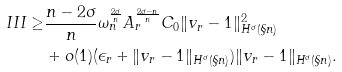Convert formula to latex. <formula><loc_0><loc_0><loc_500><loc_500>I I I \geq & \frac { n - 2 \sigma } { n } \omega _ { n } ^ { \frac { 2 \sigma } { n } } A _ { r } ^ { \frac { 2 \sigma - n } { n } } C _ { 0 } \| v _ { r } - 1 \| _ { H ^ { \sigma } ( \S n ) } ^ { 2 } \\ & + o ( 1 ) ( \epsilon _ { r } + \| v _ { r } - 1 \| _ { H ^ { \sigma } ( \S n ) } ) \| v _ { r } - 1 \| _ { H ^ { \sigma } ( \S n ) } .</formula> 